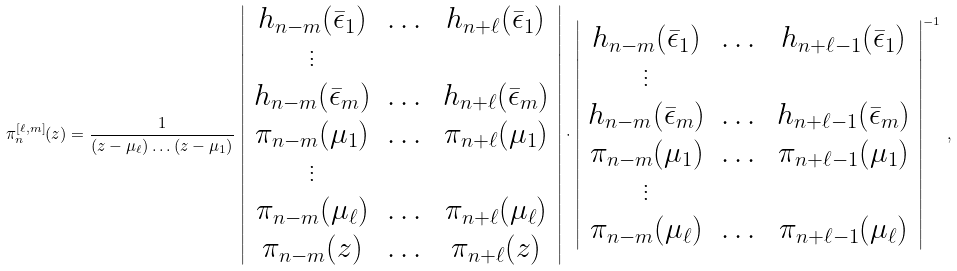<formula> <loc_0><loc_0><loc_500><loc_500>\pi _ { n } ^ { [ \ell , m ] } ( z ) = \frac { 1 } { ( z - \mu _ { \ell } ) \dots ( z - \mu _ { 1 } ) } \, \left | \begin{array} { c c c } h _ { n - m } ( \bar { \epsilon } _ { 1 } ) & \dots & h _ { n + \ell } ( \bar { \epsilon } _ { 1 } ) \\ \vdots & & \\ h _ { n - m } ( \bar { \epsilon } _ { m } ) & \dots & h _ { n + \ell } ( \bar { \epsilon } _ { m } ) \\ \pi _ { n - m } ( \mu _ { 1 } ) & \dots & \pi _ { n + \ell } ( \mu _ { 1 } ) \\ \vdots & & \\ \pi _ { n - m } ( \mu _ { \ell } ) & \dots & \pi _ { n + \ell } ( \mu _ { \ell } ) \\ \pi _ { n - m } ( z ) & \dots & \pi _ { n + \ell } ( z ) \end{array} \right | \cdot \left | \begin{array} { c c c } h _ { n - m } ( \bar { \epsilon } _ { 1 } ) & \dots & h _ { n + \ell - 1 } ( \bar { \epsilon } _ { 1 } ) \\ \vdots & & \\ h _ { n - m } ( \bar { \epsilon } _ { m } ) & \dots & h _ { n + \ell - 1 } ( \bar { \epsilon } _ { m } ) \\ \pi _ { n - m } ( \mu _ { 1 } ) & \dots & \pi _ { n + \ell - 1 } ( \mu _ { 1 } ) \\ \vdots & & \\ \pi _ { n - m } ( \mu _ { \ell } ) & \dots & \pi _ { n + \ell - 1 } ( \mu _ { \ell } ) \end{array} \right | ^ { - 1 } \, ,</formula> 